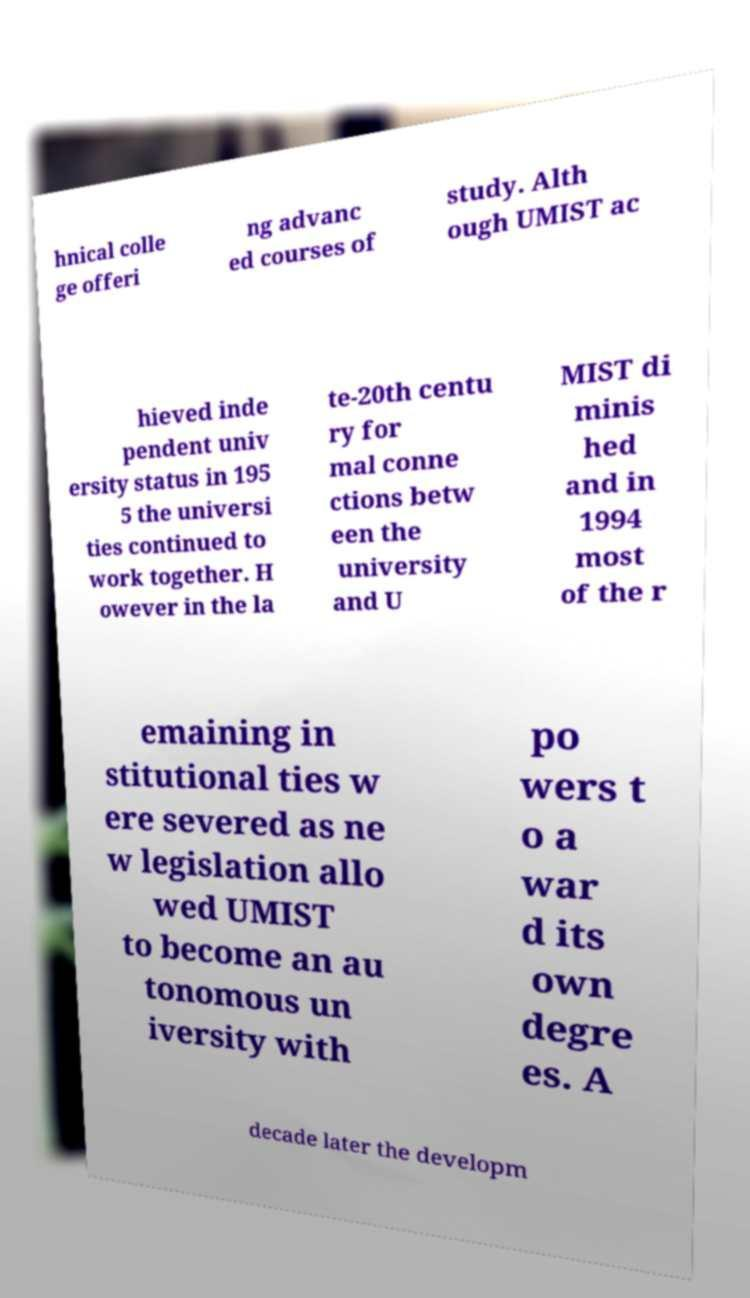What messages or text are displayed in this image? I need them in a readable, typed format. hnical colle ge offeri ng advanc ed courses of study. Alth ough UMIST ac hieved inde pendent univ ersity status in 195 5 the universi ties continued to work together. H owever in the la te-20th centu ry for mal conne ctions betw een the university and U MIST di minis hed and in 1994 most of the r emaining in stitutional ties w ere severed as ne w legislation allo wed UMIST to become an au tonomous un iversity with po wers t o a war d its own degre es. A decade later the developm 